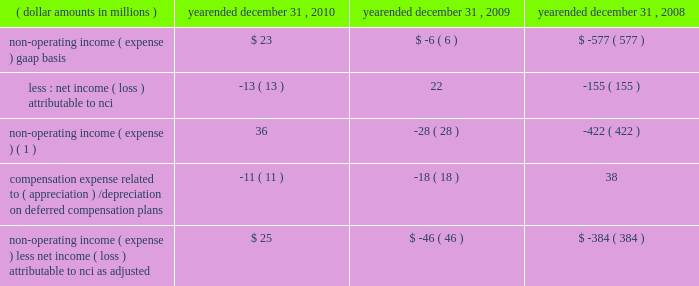4 4 m a n a g e m e n t 2019 s d i s c u s s i o n notes to table ( continued ) ( a ) ( continued ) management believes that operating income , as adjusted , and operating margin , as adjusted , are effective indicators of blackrock 2019s financial performance over time .
As such , management believes that operating income , as adjusted , and operating margin , as adjusted , provide useful disclosure to investors .
Operating income , as adjusted : bgi transaction and integration costs recorded in 2010 and 2009 consist principally of certain advisory payments , compensation expense , legal fees , marketing and promotional , occupancy and consulting expenses incurred in conjunction with the bgi transaction .
Restructuring charges recorded in 2009 and 2008 consist of compensation costs , occupancy costs and professional fees .
The expenses associated with restructuring and bgi transaction and integration costs have been deemed non-recurring by management and have been excluded from operating income , as adjusted , to help enhance the comparability of this information to the current reporting periods .
As such , management believes that operating margins exclusive of these costs are useful measures in evaluating blackrock 2019s operating performance for the respective periods .
The portion of compensation expense associated with certain long-term incentive plans ( 201cltip 201d ) that will be funded through the distribution to participants of shares of blackrock stock held by pnc and a merrill lynch cash compensation contribution , a portion of which has been received , have been excluded because these charges ultimately do not impact blackrock 2019s book value .
Compensation expense associated with appreciation/ ( depreciation ) on investments related to certain blackrock deferred compensation plans has been excluded as returns on investments set aside for these plans , which substantially offset this expense , are reported in non-operating income ( expense ) .
Operating margin , as adjusted : operating income used for measuring operating margin , as adjusted , is equal to operating income , as adjusted , excluding the impact of closed-end fund launch costs and commissions .
Management believes that excluding such costs and commissions is useful because these costs can fluctuate considerably and revenues associated with the expenditure of these costs will not fully impact the company 2019s results until future periods .
Operating margin , as adjusted , allows the company to compare performance from period-to-period by adjusting for items that may not recur , recur infrequently or may fluctuate based on market movements , such as restructuring charges , transaction and integration costs , closed-end fund launch costs , commissions paid to certain employees as compensation and fluctua- tions in compensation expense based on mark-to-market movements in investments held to fund certain compensation plans .
The company also uses operating margin , as adjusted , to monitor corporate performance and efficiency and as a benchmark to compare its performance to other companies .
Management uses both the gaap and non-gaap financial measures in evaluating the financial performance of blackrock .
The non-gaap measure by itself may pose limitations because it does not include all of the company 2019s revenues and expenses .
Revenue used for operating margin , as adjusted , excludes distribution and servicing costs paid to related parties and other third parties .
Management believes that excluding such costs is useful to blackrock because it creates consistency in the treatment for certain contracts for similar services , which due to the terms of the contracts , are accounted for under gaap on a net basis within investment advisory , administration fees and securities lending revenue .
Amortization of deferred sales commissions is excluded from revenue used for operating margin measurement , as adjusted , because such costs , over time , offset distribution fee revenue earned by the company .
Reimbursable property management compensation represented com- pensation and benefits paid to personnel of metric property management , inc .
( 201cmetric 201d ) , a subsidiary of blackrock realty advisors , inc .
( 201crealty 201d ) .
Prior to the transfer in 2008 , these employees were retained on metric 2019s payroll when certain properties were acquired by realty 2019s clients .
The related compensation and benefits were fully reimbursed by realty 2019s clients and have been excluded from revenue used for operating margin , as adjusted , because they did not bear an economic cost to blackrock .
For each of these items , blackrock excludes from revenue used for operating margin , as adjusted , the costs related to each of these items as a proxy for such offsetting revenues .
( b ) non-operating income ( expense ) , less net income ( loss ) attributable to non-controlling interests , as adjusted : non-operating income ( expense ) , less net income ( loss ) attributable to non-controlling interests ( 201cnci 201d ) , as adjusted , equals non-operating income ( expense ) , gaap basis , less net income ( loss ) attributable to nci , gaap basis , adjusted for compensation expense associated with depreciation/ ( appreciation ) on investments related to certain blackrock deferred compensation plans .
The compensation expense offset is recorded in operating income .
This compensation expense has been included in non-operating income ( expense ) , less net income ( loss ) attributable to nci , as adjusted , to offset returns on investments set aside for these plans , which are reported in non-operating income ( expense ) , gaap basis. .
Non-operating income ( expense ) ( 1 ) 36 ( 28 ) ( 422 ) compensation expense related to ( appreciation ) / depreciation on deferred compensation plans ( 11 ) ( 18 ) 38 non-operating income ( expense ) , less net income ( loss ) attributable to nci , as adjusted $ 25 ( $ 46 ) ( $ 384 ) ( 1 ) net of net income ( loss ) attributable to non-controlling interests .
Management believes that non-operating income ( expense ) , less net income ( loss ) attributable to nci , as adjusted , provides for comparability of this information to prior periods and is an effective measure for reviewing blackrock 2019s non-operating contribution to its results .
As compensation expense associated with ( appreciation ) /depreciation on investments related to certain deferred compensation plans , which is included in operating income , offsets the gain/ ( loss ) on the investments set aside for these plans , management believes that non-operating income ( expense ) , less net income ( loss ) attributable to nci , as adjusted , provides a useful measure , for both management and investors , of blackrock 2019s non-operating results that impact book value. .
What is the net change in non-operating income from 2008 to 2009? 
Computations: (-28 - -422)
Answer: 394.0. 